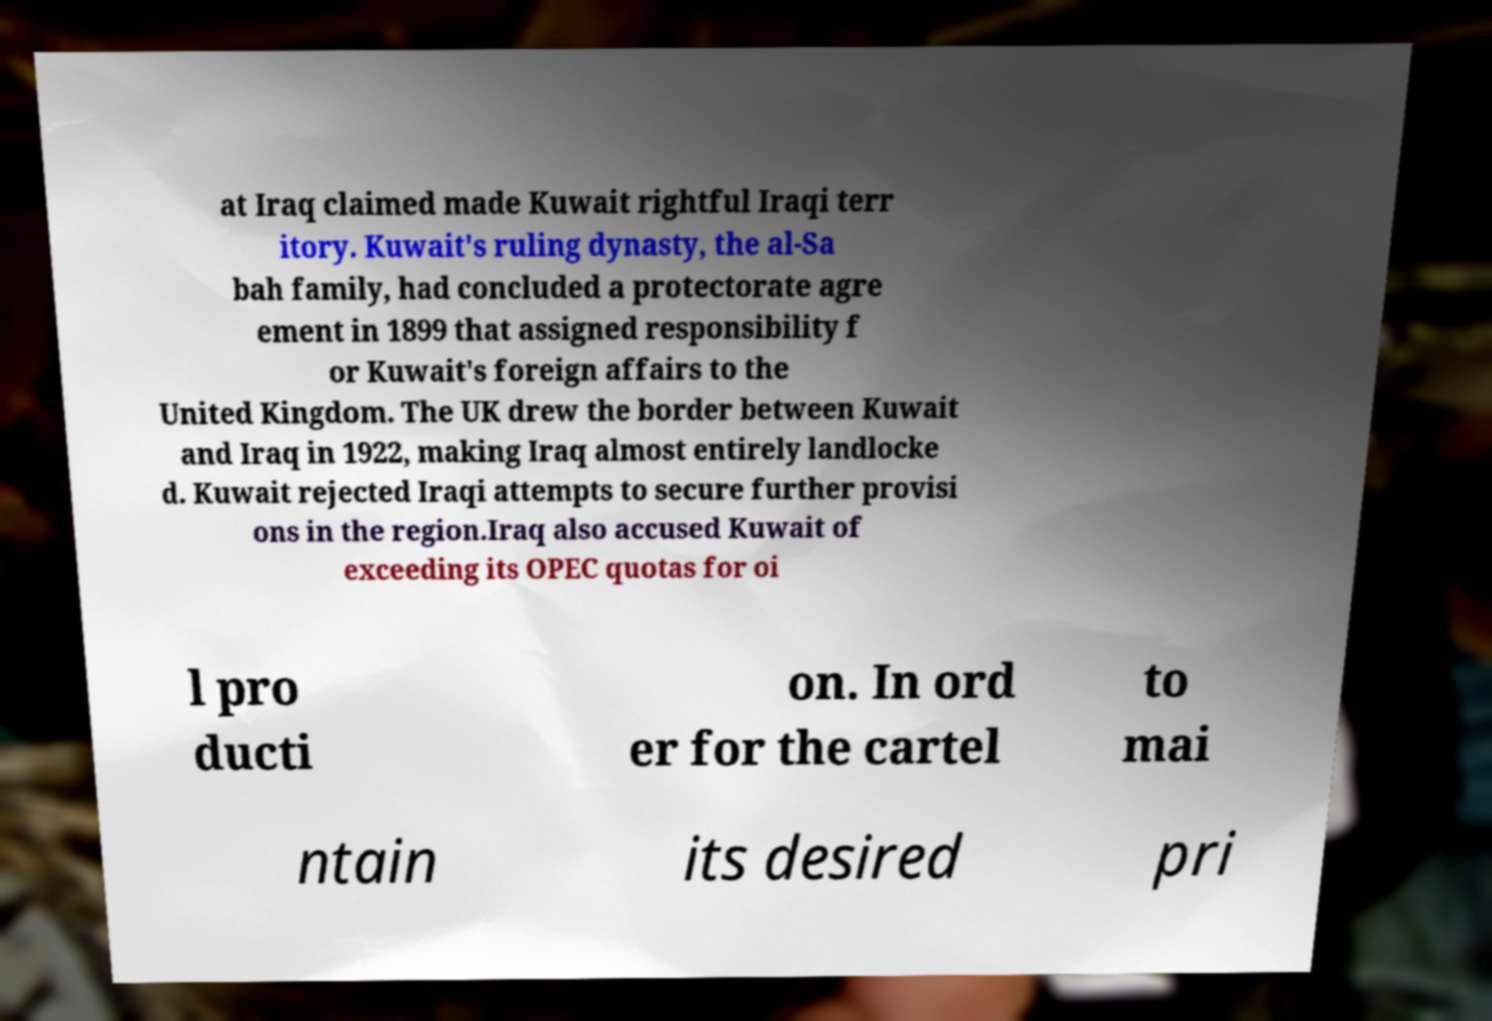Please identify and transcribe the text found in this image. at Iraq claimed made Kuwait rightful Iraqi terr itory. Kuwait's ruling dynasty, the al-Sa bah family, had concluded a protectorate agre ement in 1899 that assigned responsibility f or Kuwait's foreign affairs to the United Kingdom. The UK drew the border between Kuwait and Iraq in 1922, making Iraq almost entirely landlocke d. Kuwait rejected Iraqi attempts to secure further provisi ons in the region.Iraq also accused Kuwait of exceeding its OPEC quotas for oi l pro ducti on. In ord er for the cartel to mai ntain its desired pri 